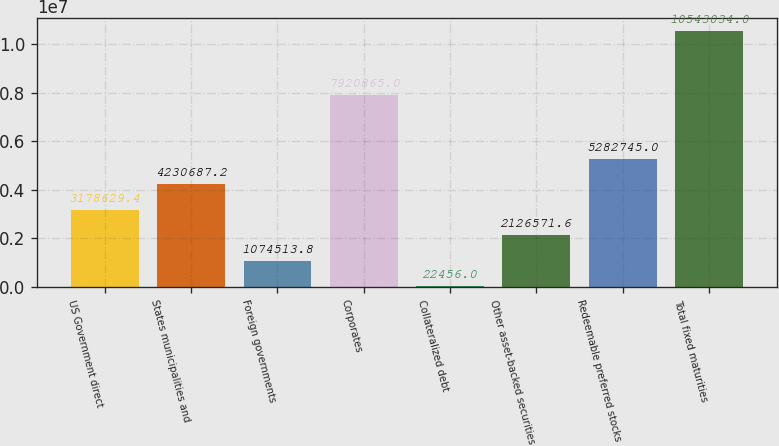Convert chart. <chart><loc_0><loc_0><loc_500><loc_500><bar_chart><fcel>US Government direct<fcel>States municipalities and<fcel>Foreign governments<fcel>Corporates<fcel>Collateralized debt<fcel>Other asset-backed securities<fcel>Redeemable preferred stocks<fcel>Total fixed maturities<nl><fcel>3.17863e+06<fcel>4.23069e+06<fcel>1.07451e+06<fcel>7.92086e+06<fcel>22456<fcel>2.12657e+06<fcel>5.28274e+06<fcel>1.0543e+07<nl></chart> 